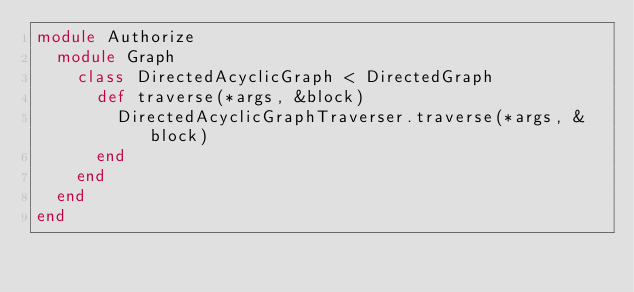Convert code to text. <code><loc_0><loc_0><loc_500><loc_500><_Ruby_>module Authorize
  module Graph
    class DirectedAcyclicGraph < DirectedGraph
      def traverse(*args, &block)
        DirectedAcyclicGraphTraverser.traverse(*args, &block)
      end
    end
  end
end</code> 